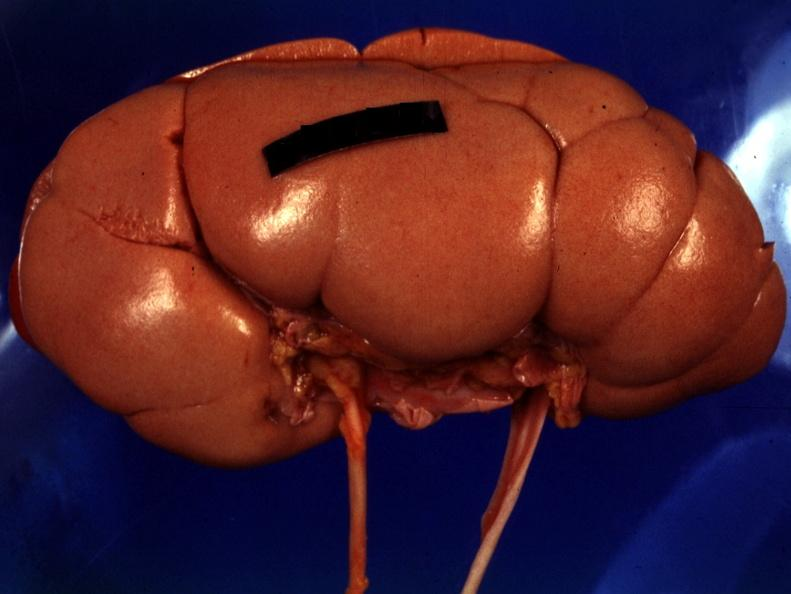does this image show good photo except for reflected lights?
Answer the question using a single word or phrase. Yes 